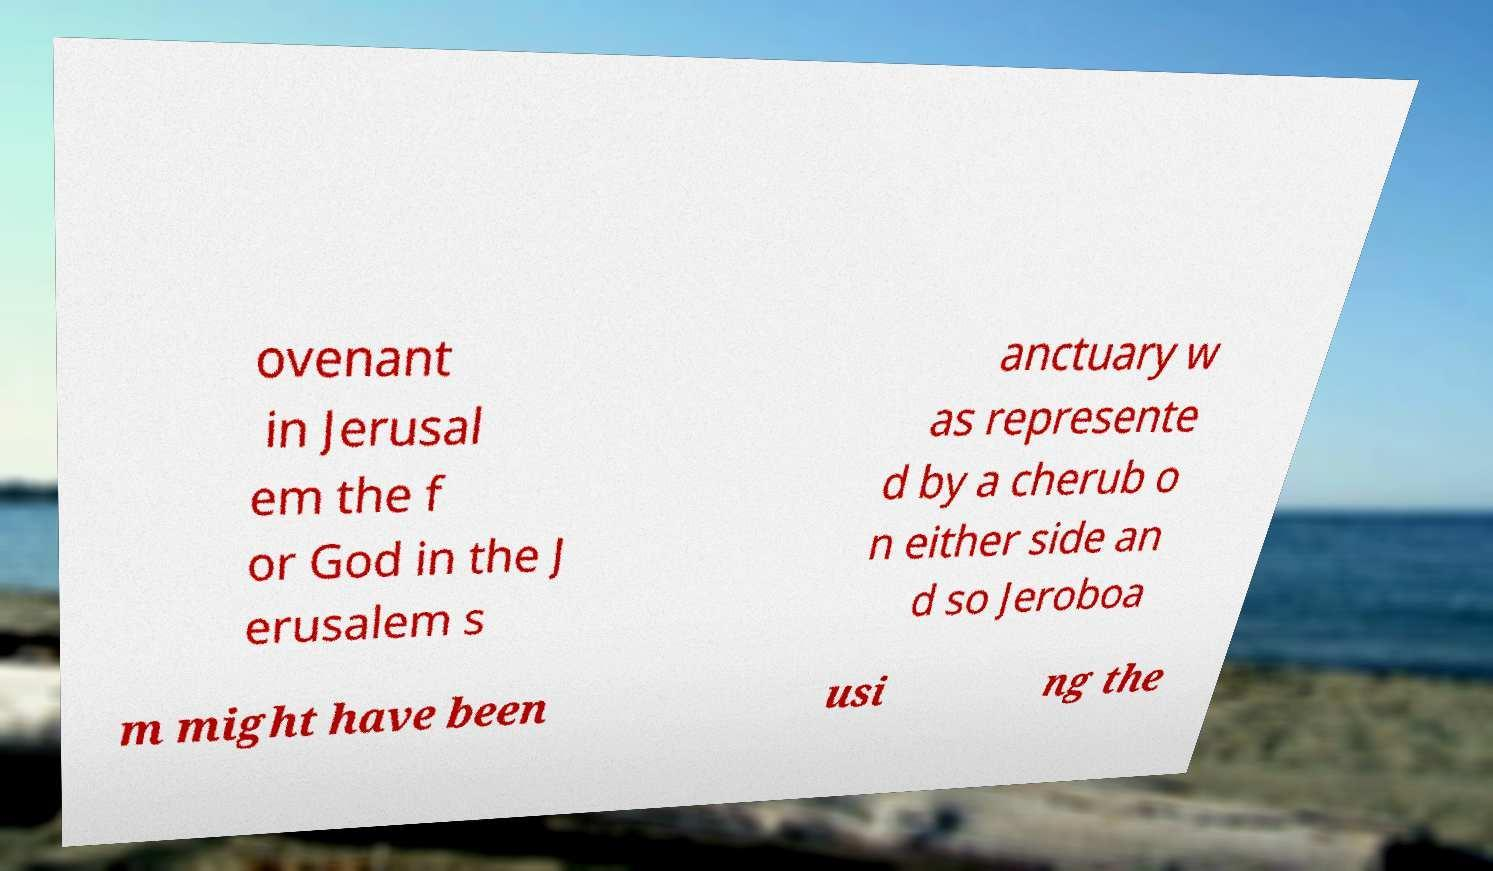Can you accurately transcribe the text from the provided image for me? ovenant in Jerusal em the f or God in the J erusalem s anctuary w as represente d by a cherub o n either side an d so Jeroboa m might have been usi ng the 